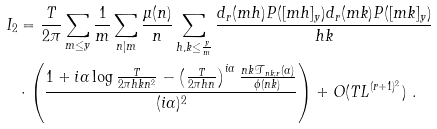Convert formula to latex. <formula><loc_0><loc_0><loc_500><loc_500>I _ { 2 } & = \frac { T } { 2 \pi } \sum _ { m \leq y } \frac { 1 } { m } \sum _ { n | m } \frac { \mu ( n ) } { n } \sum _ { h , k \leq \frac { y } { m } } \frac { d _ { r } ( m h ) P ( [ m h ] _ { y } ) d _ { r } ( m k ) P ( [ m k ] _ { y } ) } { h k } \\ & \cdot \left ( \frac { 1 + i \alpha \log \frac { T } { 2 \pi h k n ^ { 2 } } - \left ( \frac { T } { 2 \pi h n } \right ) ^ { i \alpha } \frac { n k \mathcal { T } _ { n k ; r } ( \alpha ) } { \phi ( n k ) } } { ( i \alpha ) ^ { 2 } } \right ) + O ( T L ^ { ( r + 1 ) ^ { 2 } } ) \ .</formula> 